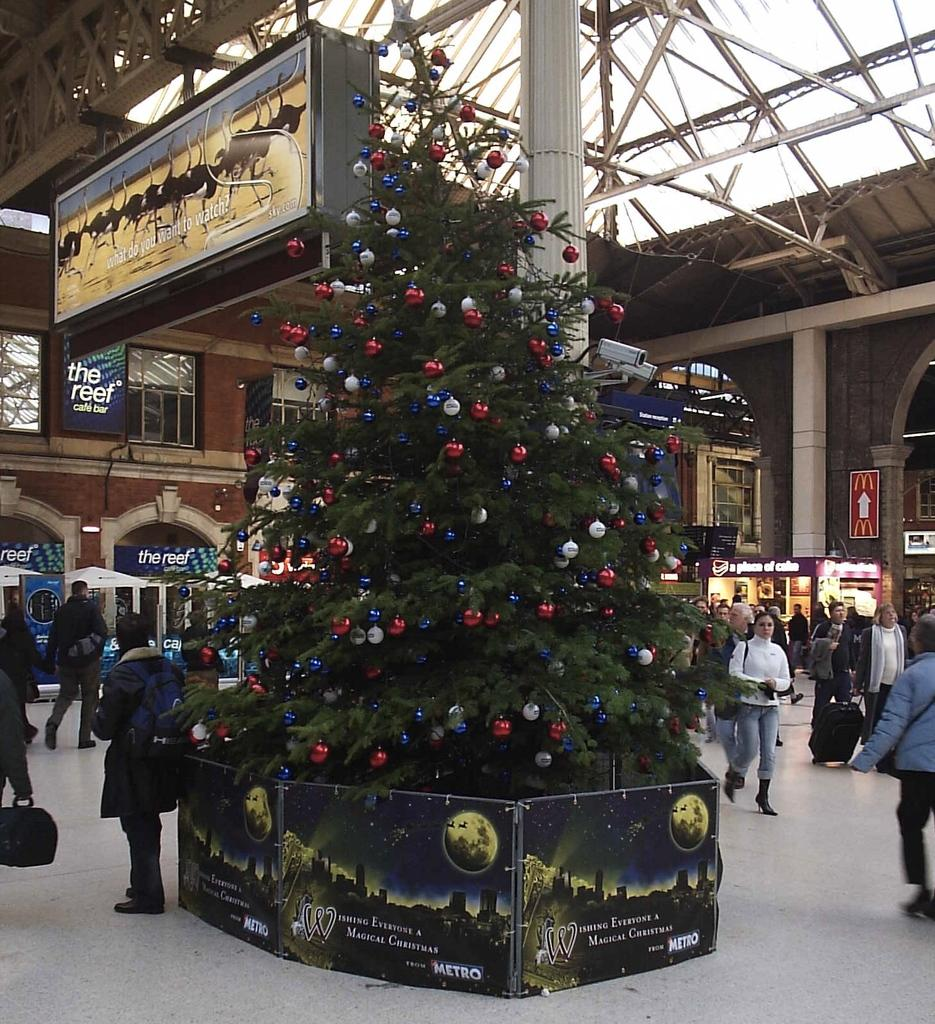What type of natural element is present in the image? There is a tree in the image. What type of man-made structure is present in the image? There is a building with windows in the image. What are the people in the image doing? There are people standing and walking in the image. What type of reward is being given to the pet in the image? There is no pet present in the image, so it is not possible to determine if a reward is being given. What flavor of cake is being served in the image? There is no cake present in the image. 